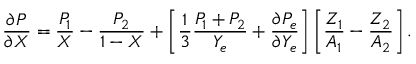<formula> <loc_0><loc_0><loc_500><loc_500>{ \frac { \partial P } { \partial X } } = { \frac { P _ { 1 } } { X } } - { \frac { P _ { 2 } } { 1 - X } } + \left [ { \frac { 1 } { 3 } } { \frac { P _ { 1 } + P _ { 2 } } { Y _ { e } } } + { \frac { \partial P _ { e } } { \partial Y _ { e } } } \right ] \left [ { \frac { Z _ { 1 } } { A _ { 1 } } } - { \frac { Z _ { 2 } } { A _ { 2 } } } \right ] .</formula> 